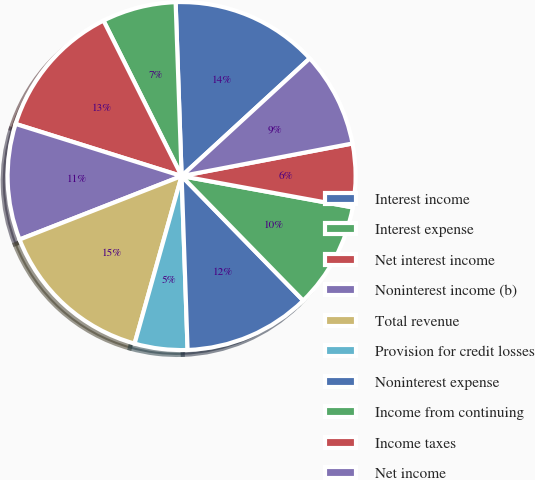Convert chart. <chart><loc_0><loc_0><loc_500><loc_500><pie_chart><fcel>Interest income<fcel>Interest expense<fcel>Net interest income<fcel>Noninterest income (b)<fcel>Total revenue<fcel>Provision for credit losses<fcel>Noninterest expense<fcel>Income from continuing<fcel>Income taxes<fcel>Net income<nl><fcel>13.72%<fcel>6.86%<fcel>12.74%<fcel>10.78%<fcel>14.7%<fcel>4.9%<fcel>11.76%<fcel>9.8%<fcel>5.88%<fcel>8.82%<nl></chart> 